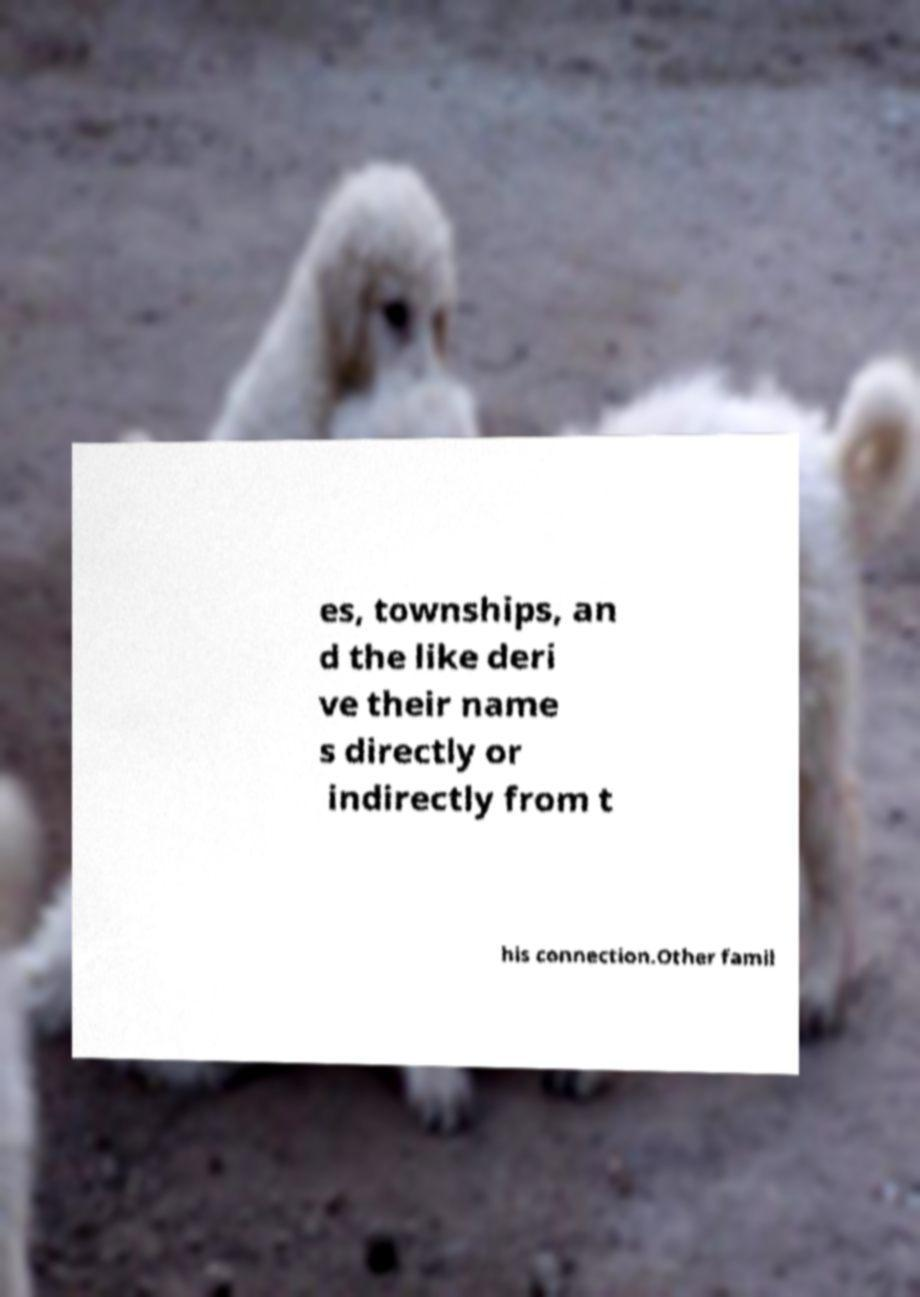Can you accurately transcribe the text from the provided image for me? es, townships, an d the like deri ve their name s directly or indirectly from t his connection.Other famil 